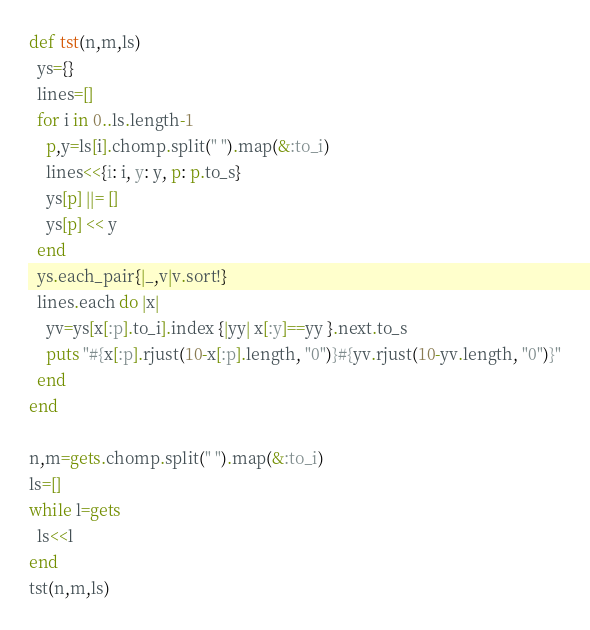Convert code to text. <code><loc_0><loc_0><loc_500><loc_500><_Ruby_>def tst(n,m,ls)
  ys={}
  lines=[]
  for i in 0..ls.length-1
    p,y=ls[i].chomp.split(" ").map(&:to_i)
    lines<<{i: i, y: y, p: p.to_s}
    ys[p] ||= []
    ys[p] << y
  end
  ys.each_pair{|_,v|v.sort!}
  lines.each do |x|
    yv=ys[x[:p].to_i].index {|yy| x[:y]==yy }.next.to_s
    puts "#{x[:p].rjust(10-x[:p].length, "0")}#{yv.rjust(10-yv.length, "0")}"
  end
end

n,m=gets.chomp.split(" ").map(&:to_i)
ls=[]
while l=gets
  ls<<l
end
tst(n,m,ls)</code> 